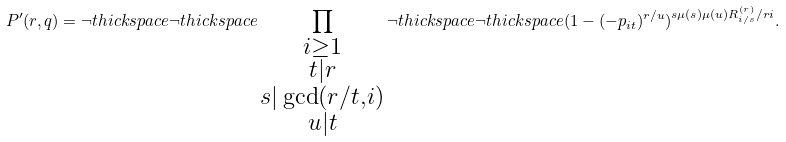Convert formula to latex. <formula><loc_0><loc_0><loc_500><loc_500>P ^ { \prime } ( r , q ) = \neg t h i c k s p a c e \neg t h i c k s p a c e \prod _ { \substack { i \geq 1 \\ t | r \\ s | \gcd ( r / t , i ) \\ u | t } } \neg t h i c k s p a c e \neg t h i c k s p a c e ( 1 - ( - p _ { i t } ) ^ { r / u } ) ^ { s \mu ( s ) \mu ( u ) R _ { i / s } ^ { ( r ) } / r i } .</formula> 